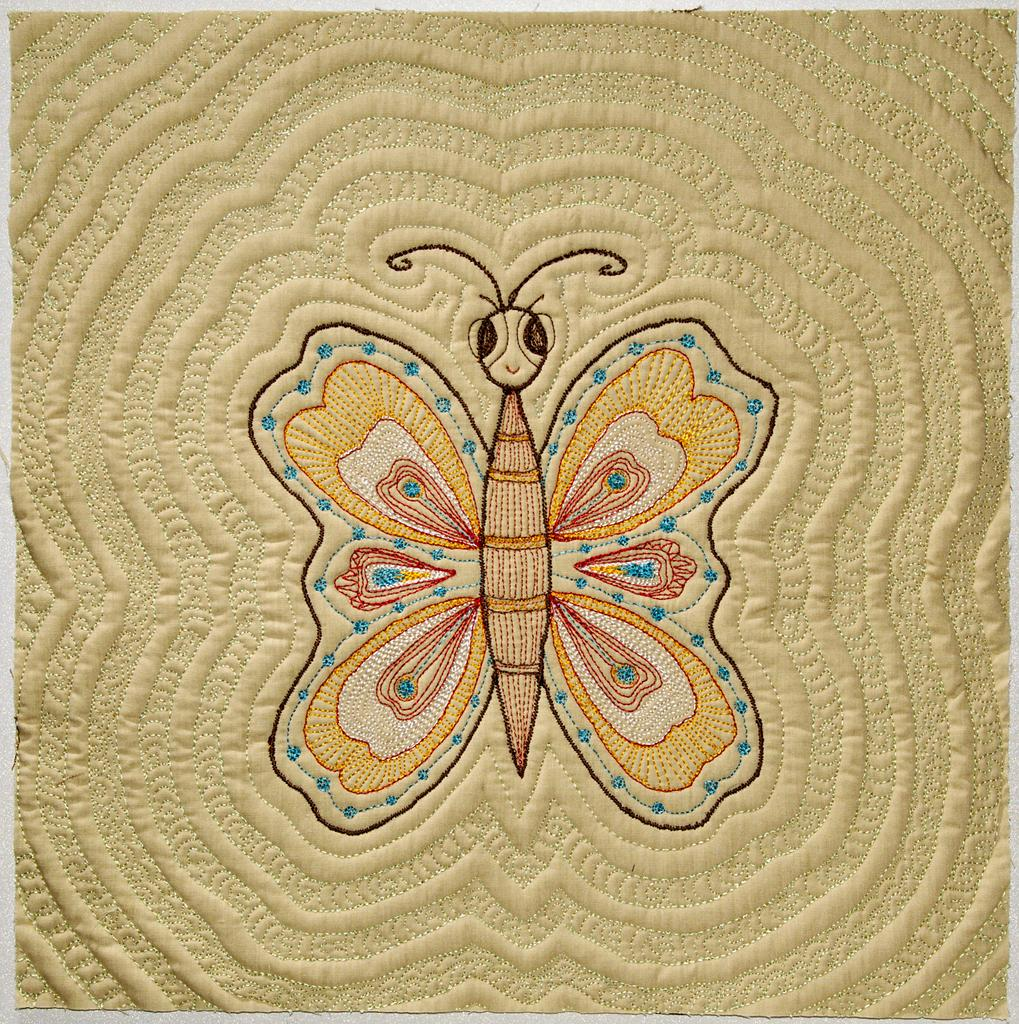What is present in the image that has a design? There is a cloth in the image that has a butterfly design. Can you describe the design on the cloth? The design on the cloth is a butterfly. How many corks are attached to the butterfly design on the cloth? There are no corks present in the image, as the design on the cloth is a butterfly. 